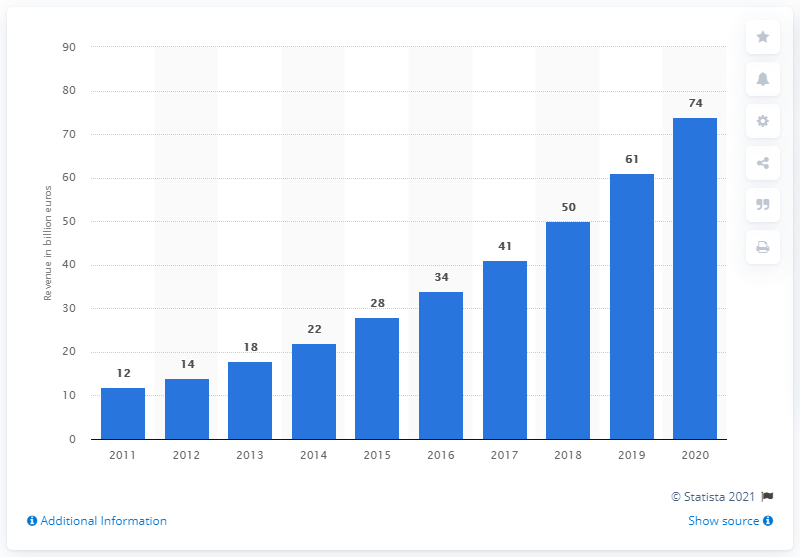List a handful of essential elements in this visual. According to CLSA Asia-Pacific Market, luxury sales revenue in China is projected to reach approximately 74 billion USD in 2020. 